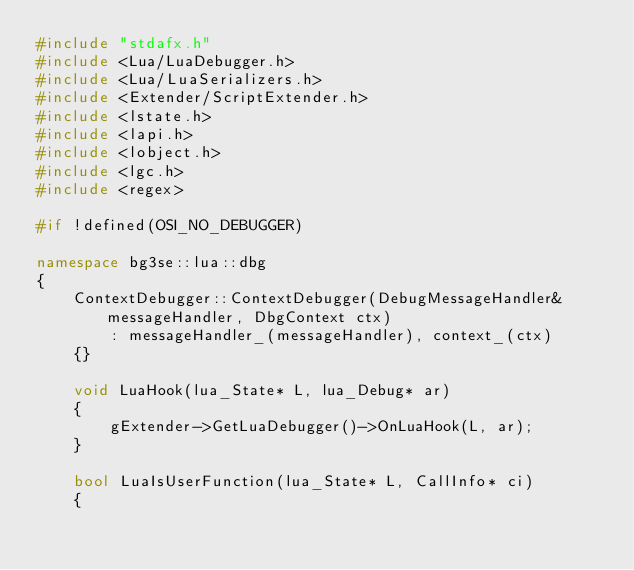Convert code to text. <code><loc_0><loc_0><loc_500><loc_500><_C++_>#include "stdafx.h"
#include <Lua/LuaDebugger.h>
#include <Lua/LuaSerializers.h>
#include <Extender/ScriptExtender.h>
#include <lstate.h>
#include <lapi.h>
#include <lobject.h>
#include <lgc.h>
#include <regex>

#if !defined(OSI_NO_DEBUGGER)

namespace bg3se::lua::dbg
{
	ContextDebugger::ContextDebugger(DebugMessageHandler& messageHandler, DbgContext ctx)
		: messageHandler_(messageHandler), context_(ctx)
	{}

	void LuaHook(lua_State* L, lua_Debug* ar)
	{
		gExtender->GetLuaDebugger()->OnLuaHook(L, ar);
	}

	bool LuaIsUserFunction(lua_State* L, CallInfo* ci)
	{</code> 